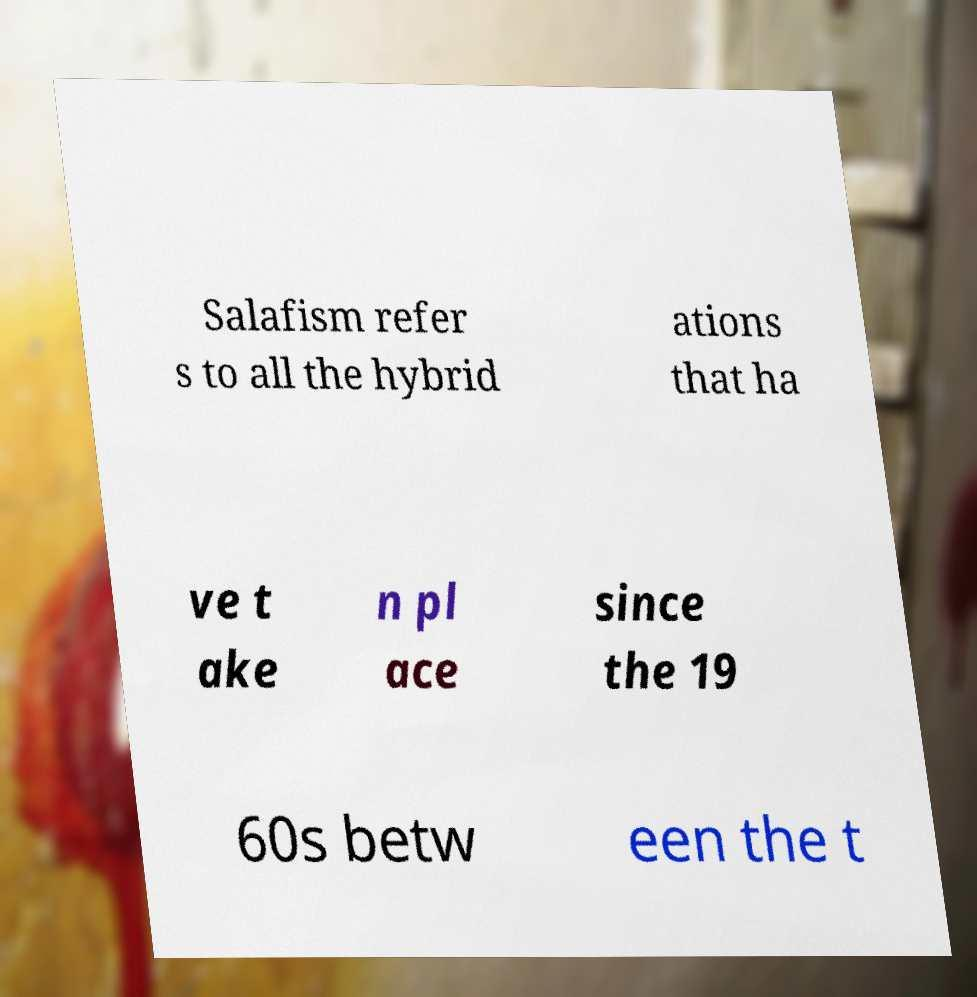What messages or text are displayed in this image? I need them in a readable, typed format. Salafism refer s to all the hybrid ations that ha ve t ake n pl ace since the 19 60s betw een the t 